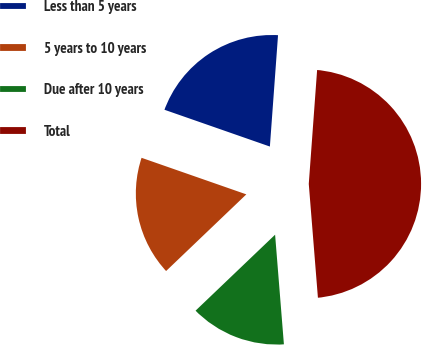<chart> <loc_0><loc_0><loc_500><loc_500><pie_chart><fcel>Less than 5 years<fcel>5 years to 10 years<fcel>Due after 10 years<fcel>Total<nl><fcel>20.82%<fcel>17.48%<fcel>14.14%<fcel>47.56%<nl></chart> 